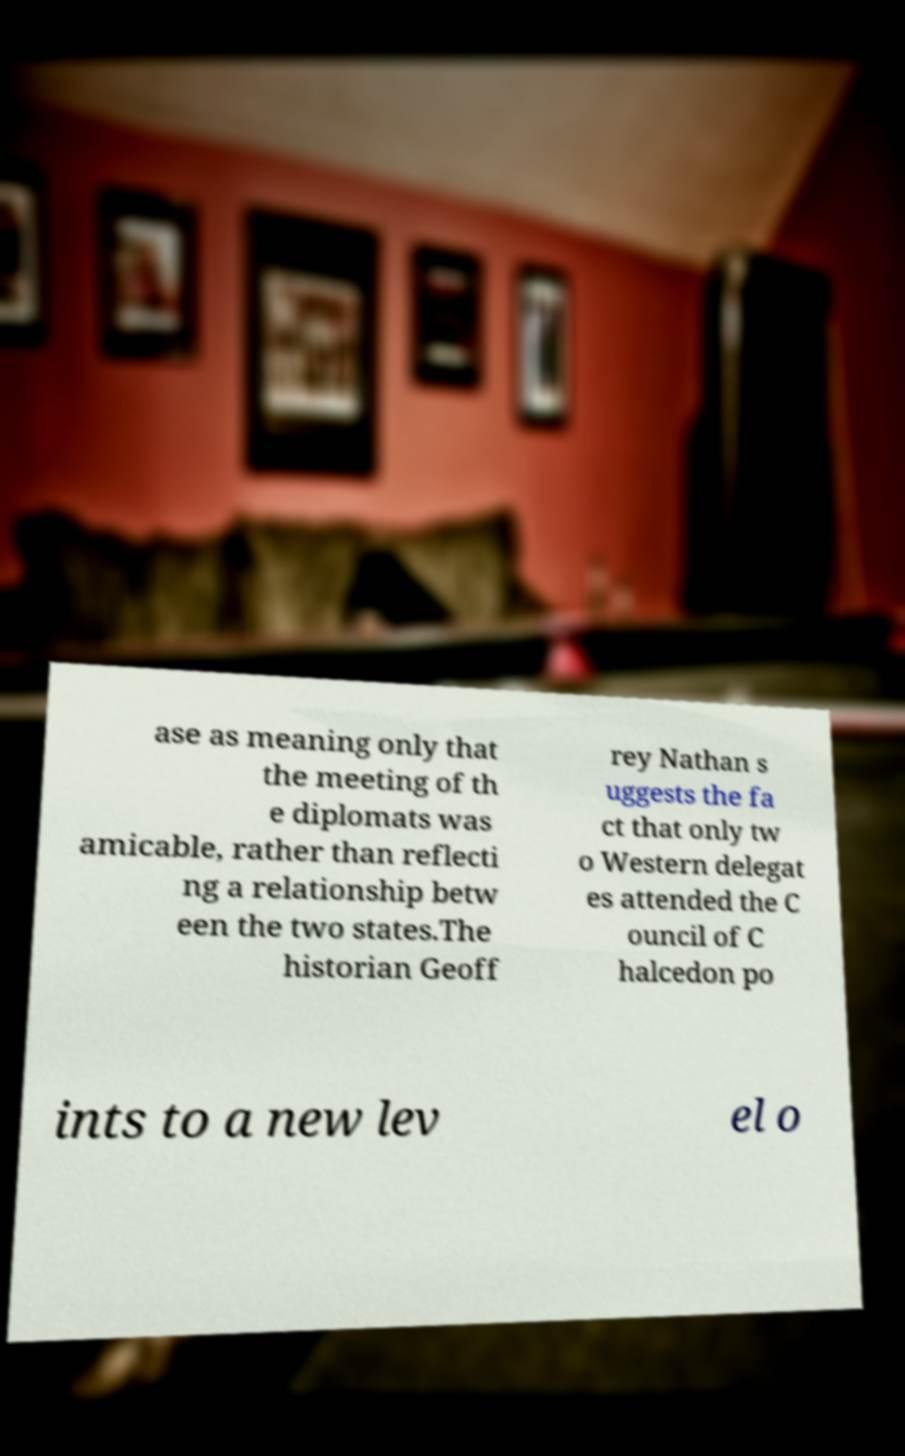I need the written content from this picture converted into text. Can you do that? ase as meaning only that the meeting of th e diplomats was amicable, rather than reflecti ng a relationship betw een the two states.The historian Geoff rey Nathan s uggests the fa ct that only tw o Western delegat es attended the C ouncil of C halcedon po ints to a new lev el o 